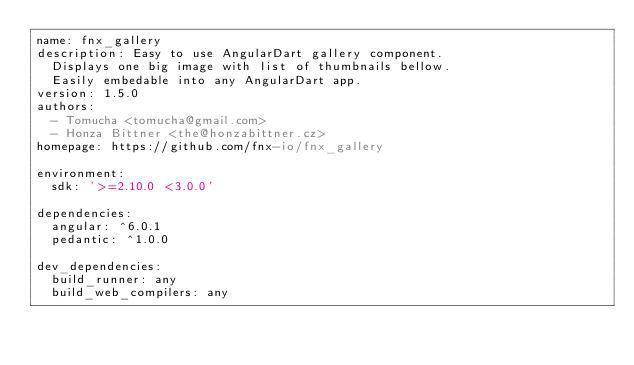<code> <loc_0><loc_0><loc_500><loc_500><_YAML_>name: fnx_gallery
description: Easy to use AngularDart gallery component.
  Displays one big image with list of thumbnails bellow.
  Easily embedable into any AngularDart app.
version: 1.5.0
authors:
  - Tomucha <tomucha@gmail.com>
  - Honza Bittner <the@honzabittner.cz>
homepage: https://github.com/fnx-io/fnx_gallery

environment:
  sdk: '>=2.10.0 <3.0.0'

dependencies:
  angular: ^6.0.1
  pedantic: ^1.0.0

dev_dependencies:
  build_runner: any
  build_web_compilers: any
</code> 